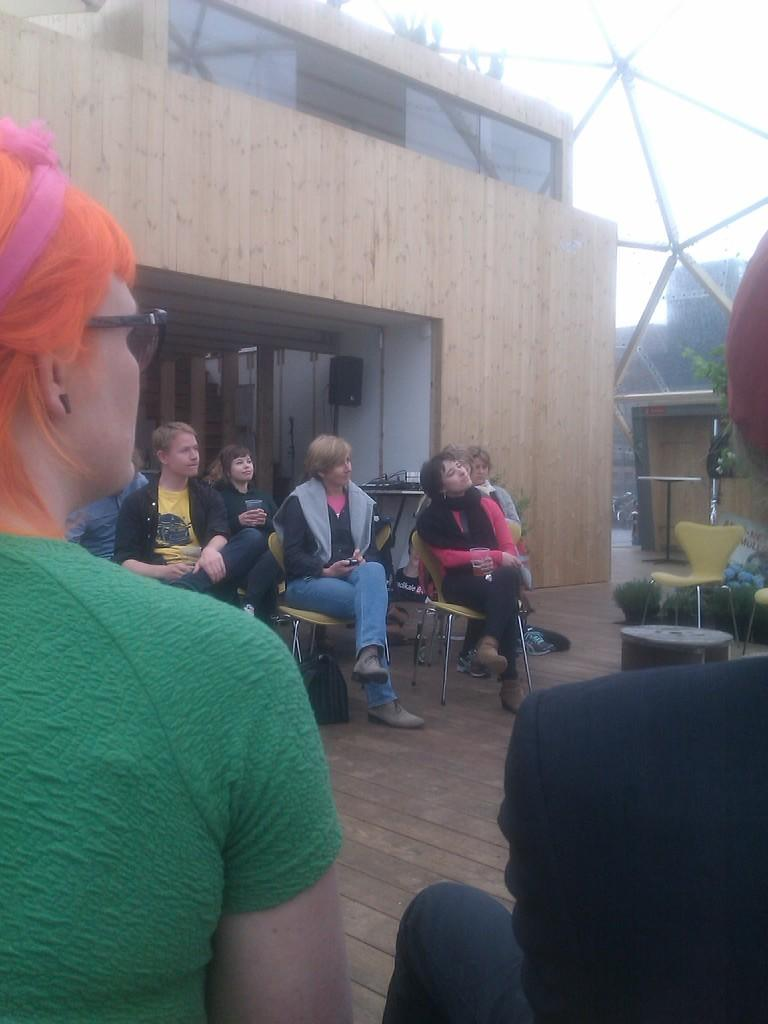What are the persons in the image doing? The persons in the image are sitting on chairs. What is the color of the floor in the image? The floor is brown in color. What type of structure can be seen in the image? There is a building in the image. Can you describe the black colored object in the image? There is a black colored object in the image, but its specific nature is not mentioned in the facts. How many chairs are visible in the image? There is at least one chair in the image, as the persons are sitting on chairs. What type of vegetation is present in the image? There is a tree in the image. What can be seen in the background of the image? The sky is visible in the background of the image. What type of breakfast is being served on the table in the image? There is no table or breakfast present in the image. Can you describe the behavior of the cat in the image? There is no cat present in the image. What type of beef is being cooked in the image? There is no beef or cooking activity present in the image. 